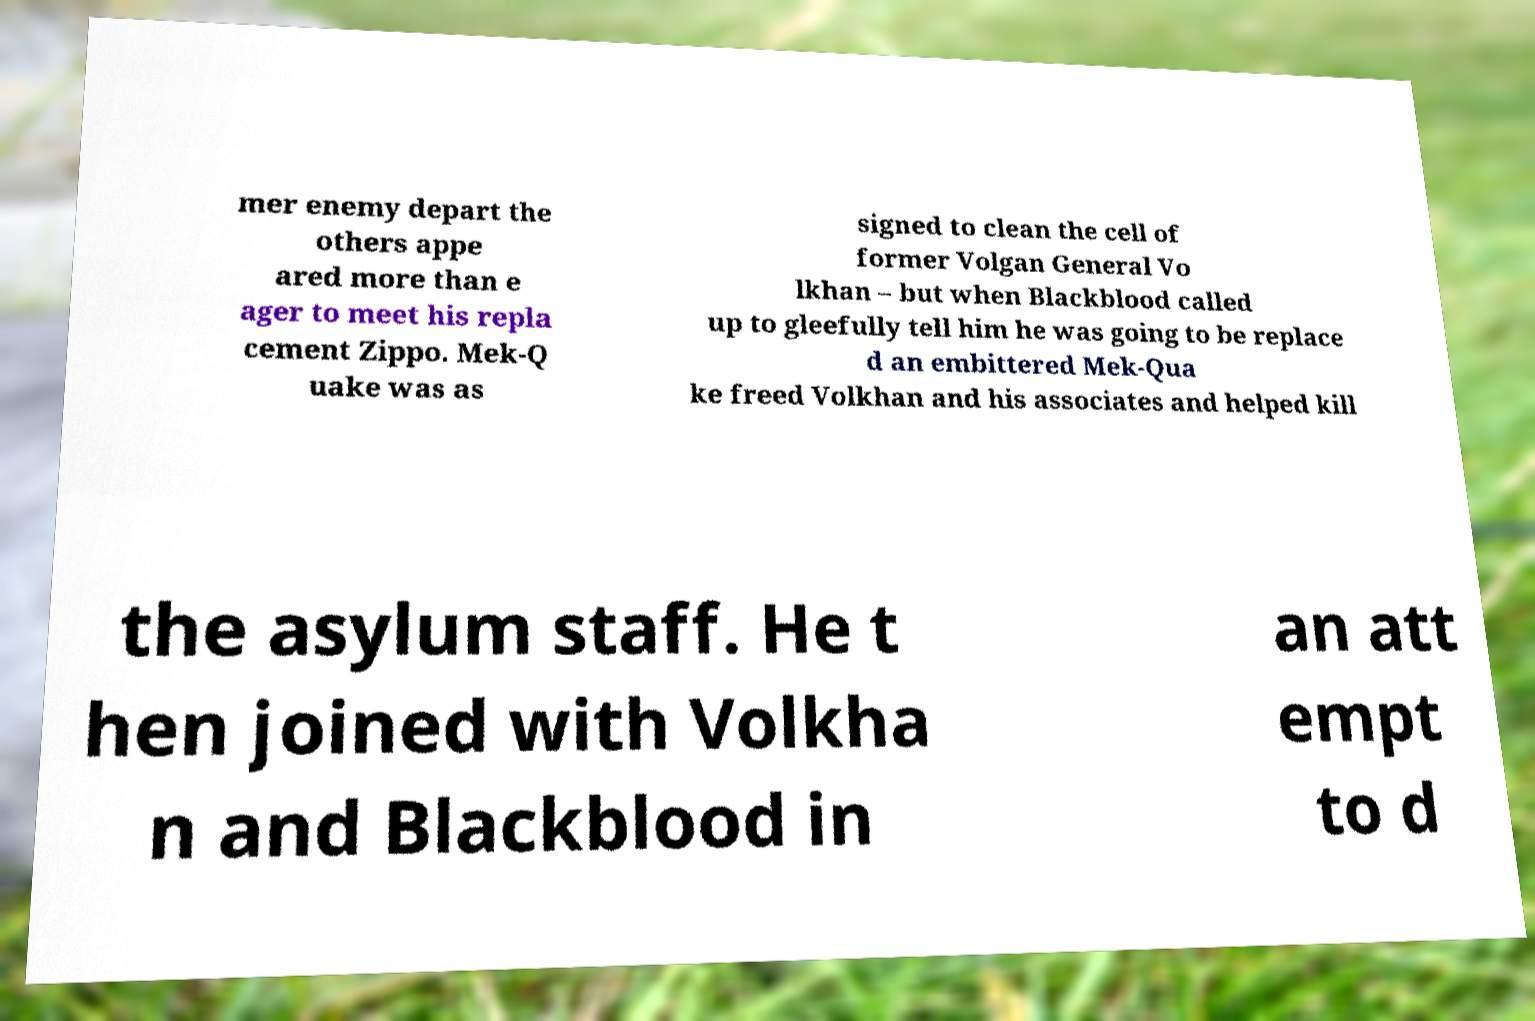For documentation purposes, I need the text within this image transcribed. Could you provide that? mer enemy depart the others appe ared more than e ager to meet his repla cement Zippo. Mek-Q uake was as signed to clean the cell of former Volgan General Vo lkhan – but when Blackblood called up to gleefully tell him he was going to be replace d an embittered Mek-Qua ke freed Volkhan and his associates and helped kill the asylum staff. He t hen joined with Volkha n and Blackblood in an att empt to d 